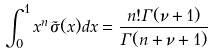Convert formula to latex. <formula><loc_0><loc_0><loc_500><loc_500>\int _ { 0 } ^ { 1 } x ^ { n } \tilde { \sigma } ( x ) d x = \frac { n ! \Gamma ( \nu + 1 ) } { \Gamma ( n + \nu + 1 ) }</formula> 